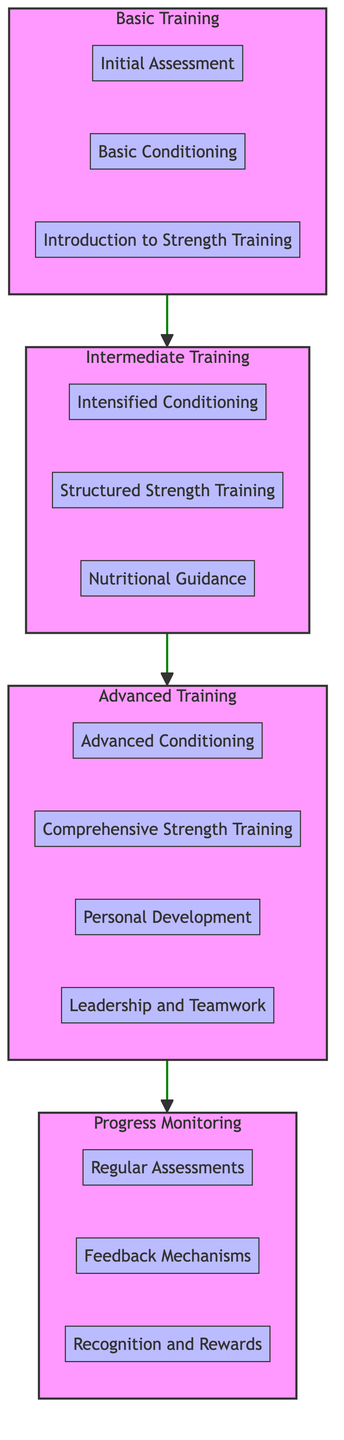What are the components of Advanced Training? The diagram outlines the components of Advanced Training, which are located within the "Advanced Training" subgraph. They include Advanced Conditioning, Comprehensive Strength Training, Personal Development, and Leadership and Teamwork.
Answer: Advanced Conditioning, Comprehensive Strength Training, Personal Development, Leadership and Teamwork How many levels are in the training process? The diagram clearly indicates four distinct levels in the physical fitness training process: Basic Training, Intermediate Training, Advanced Training, and Progress Monitoring.
Answer: Four What is the first component in Basic Training? Basic Training lists its components within the "Basic Training" subgraph. The first component is Initial Assessment, which is the starting point of the training process.
Answer: Initial Assessment What comes before Progress Monitoring? The flow of the diagram indicates a clear path from Advanced Training leading directly to Progress Monitoring. Therefore, the component that comes before Progress Monitoring is Advanced Training.
Answer: Advanced Training How many components are there under Intermediate Training? The Intermediate Training subgraph specifies three components: Intensified Conditioning, Structured Strength Training, and Nutritional Guidance, which can be directly counted for an answer.
Answer: Three What is the relationship between Basic Conditioning and Structured Strength Training? Basic Conditioning is a component of Basic Training while Structured Strength Training is a component of Intermediate Training. This indicates a sequential relationship where Basic Conditioning leads to Enhanced Performance, eventually requiring Structured Strength Training in the next level.
Answer: Sequential relationship What are two goals of Personal Development in Advanced Training? Within the Advanced Training subgraph, Personal Development encourages cadets to set personal fitness goals and develop individualized training plans. These are the two specific goals outlined for this component.
Answer: Set personal fitness goals, develop individualized training plans What type of training follows Introduction to Strength Training? The diagram shows a progression from Basic Training to Intermediate Training, so the type of training that follows Introduction to Strength Training in the flow is Intensified Conditioning in Intermediate Training.
Answer: Intensified Conditioning What is the final step in the fitness progression? The final step, based on the upward flow in the diagram, is Progress Monitoring, which is at the top of the flow chart and represents the last phase in the fitness building process.
Answer: Progress Monitoring 